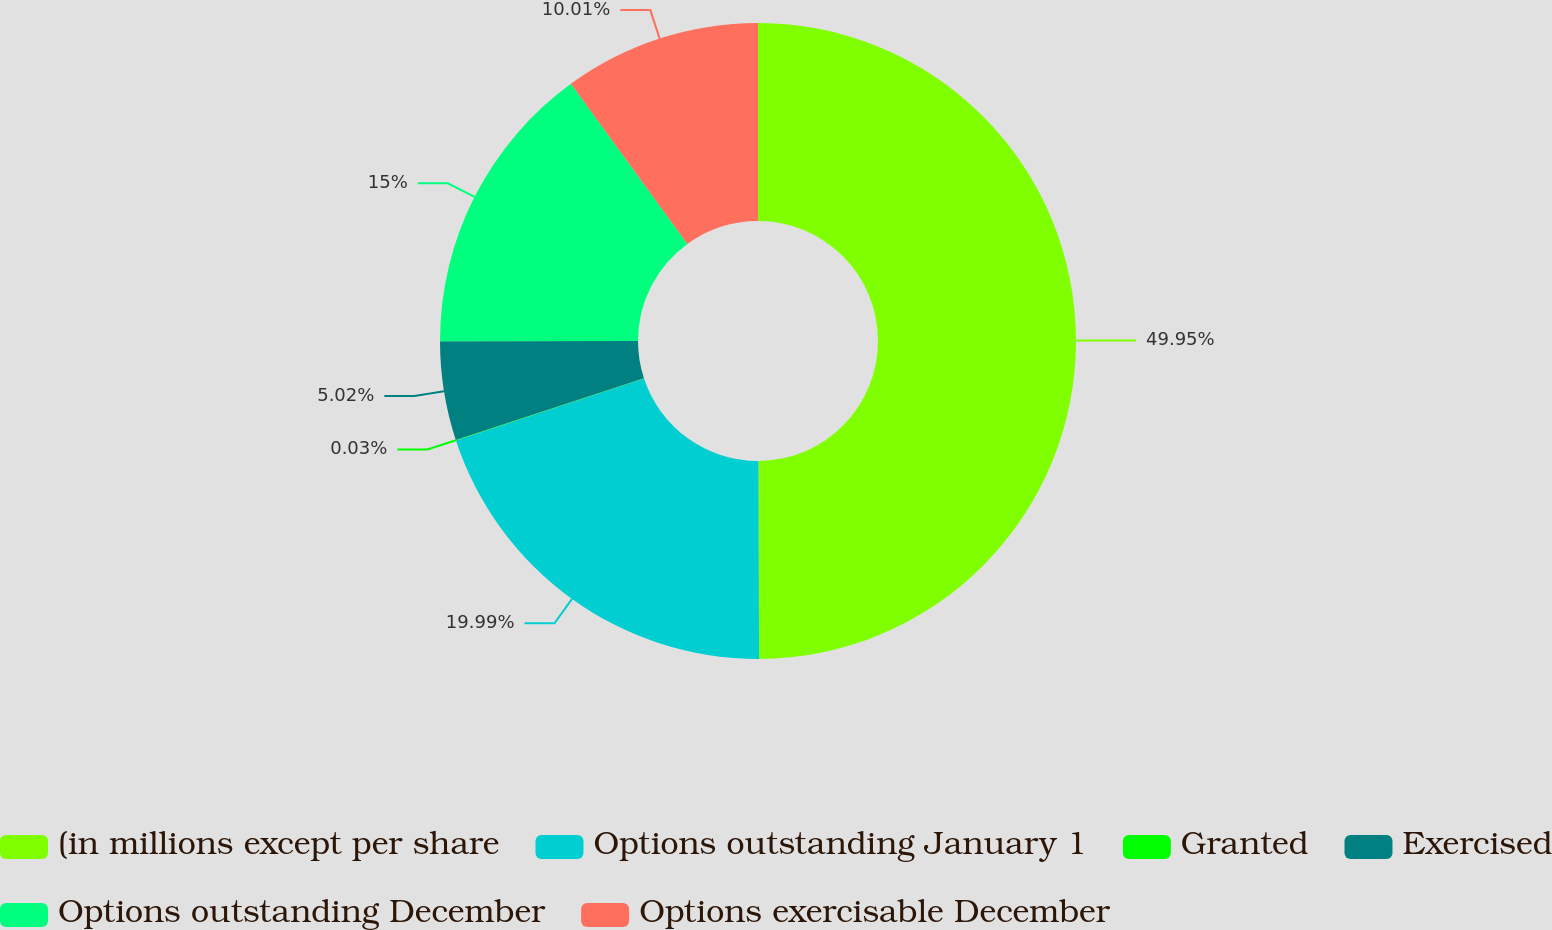Convert chart. <chart><loc_0><loc_0><loc_500><loc_500><pie_chart><fcel>(in millions except per share<fcel>Options outstanding January 1<fcel>Granted<fcel>Exercised<fcel>Options outstanding December<fcel>Options exercisable December<nl><fcel>49.94%<fcel>19.99%<fcel>0.03%<fcel>5.02%<fcel>15.0%<fcel>10.01%<nl></chart> 